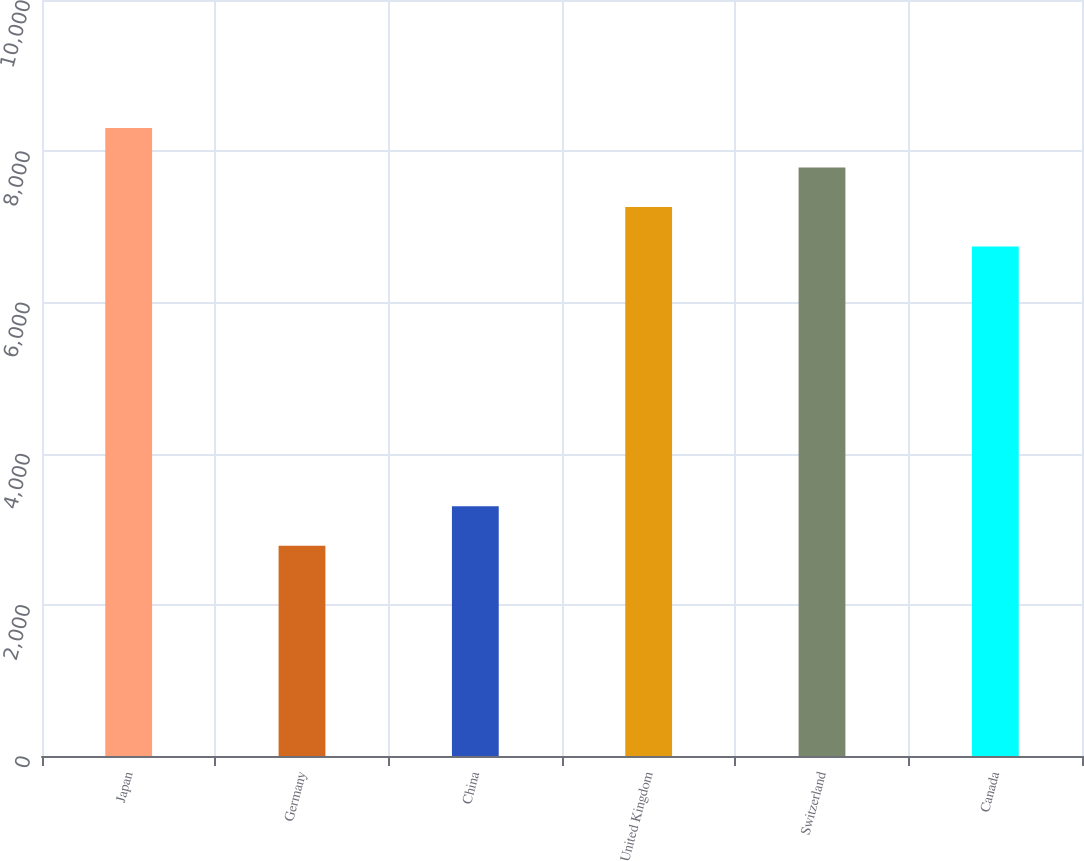Convert chart. <chart><loc_0><loc_0><loc_500><loc_500><bar_chart><fcel>Japan<fcel>Germany<fcel>China<fcel>United Kingdom<fcel>Switzerland<fcel>Canada<nl><fcel>8307<fcel>2782<fcel>3304<fcel>7263<fcel>7785<fcel>6741<nl></chart> 